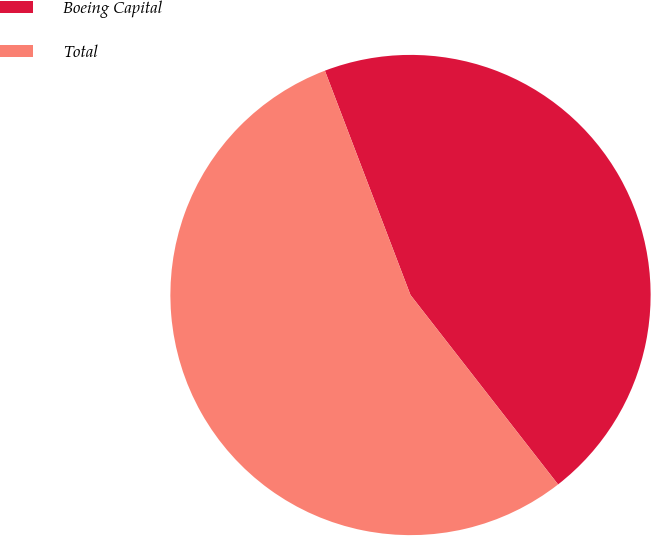Convert chart to OTSL. <chart><loc_0><loc_0><loc_500><loc_500><pie_chart><fcel>Boeing Capital<fcel>Total<nl><fcel>45.27%<fcel>54.73%<nl></chart> 